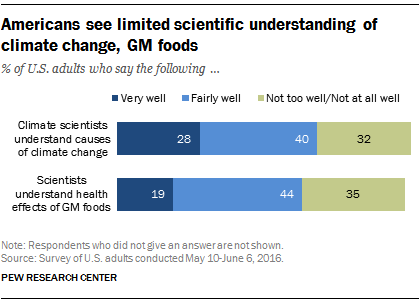Specify some key components in this picture. GM foods are understood by scientists to have health effects that are well understood, while the causes of climate change are not well understood by climate scientists. The color that value 32 represents is green. 